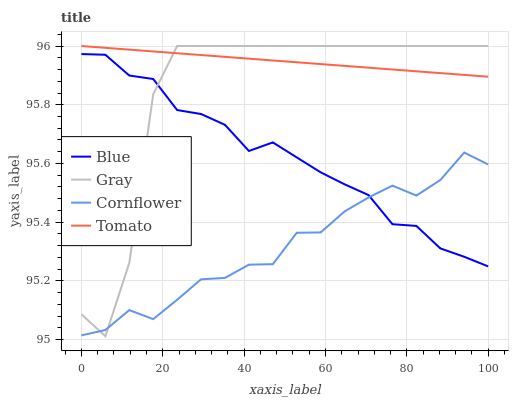Does Cornflower have the minimum area under the curve?
Answer yes or no. Yes. Does Tomato have the maximum area under the curve?
Answer yes or no. Yes. Does Gray have the minimum area under the curve?
Answer yes or no. No. Does Gray have the maximum area under the curve?
Answer yes or no. No. Is Tomato the smoothest?
Answer yes or no. Yes. Is Gray the roughest?
Answer yes or no. Yes. Is Gray the smoothest?
Answer yes or no. No. Is Tomato the roughest?
Answer yes or no. No. Does Tomato have the lowest value?
Answer yes or no. No. Does Cornflower have the highest value?
Answer yes or no. No. Is Blue less than Tomato?
Answer yes or no. Yes. Is Tomato greater than Cornflower?
Answer yes or no. Yes. Does Blue intersect Tomato?
Answer yes or no. No. 